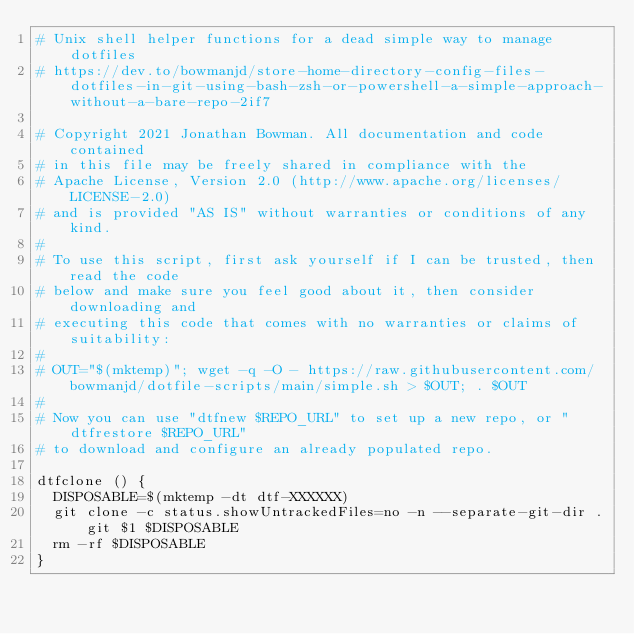<code> <loc_0><loc_0><loc_500><loc_500><_Bash_># Unix shell helper functions for a dead simple way to manage dotfiles
# https://dev.to/bowmanjd/store-home-directory-config-files-dotfiles-in-git-using-bash-zsh-or-powershell-a-simple-approach-without-a-bare-repo-2if7

# Copyright 2021 Jonathan Bowman. All documentation and code contained
# in this file may be freely shared in compliance with the
# Apache License, Version 2.0 (http://www.apache.org/licenses/LICENSE-2.0)
# and is provided "AS IS" without warranties or conditions of any kind.
#
# To use this script, first ask yourself if I can be trusted, then read the code
# below and make sure you feel good about it, then consider downloading and
# executing this code that comes with no warranties or claims of suitability:
#
# OUT="$(mktemp)"; wget -q -O - https://raw.githubusercontent.com/bowmanjd/dotfile-scripts/main/simple.sh > $OUT; . $OUT
#
# Now you can use "dtfnew $REPO_URL" to set up a new repo, or "dtfrestore $REPO_URL"
# to download and configure an already populated repo.

dtfclone () {
  DISPOSABLE=$(mktemp -dt dtf-XXXXXX)
  git clone -c status.showUntrackedFiles=no -n --separate-git-dir .git $1 $DISPOSABLE
  rm -rf $DISPOSABLE
}

</code> 